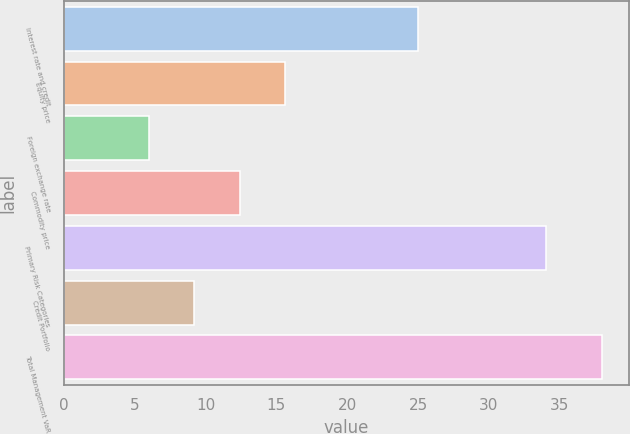Convert chart. <chart><loc_0><loc_0><loc_500><loc_500><bar_chart><fcel>Interest rate and credit<fcel>Equity price<fcel>Foreign exchange rate<fcel>Commodity price<fcel>Primary Risk Categories<fcel>Credit Portfolio<fcel>Total Management VaR<nl><fcel>25<fcel>15.6<fcel>6<fcel>12.4<fcel>34<fcel>9.2<fcel>38<nl></chart> 